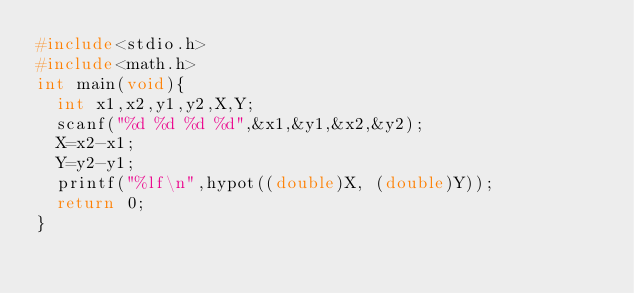Convert code to text. <code><loc_0><loc_0><loc_500><loc_500><_C_>#include<stdio.h>
#include<math.h>
int main(void){
	int x1,x2,y1,y2,X,Y;
	scanf("%d %d %d %d",&x1,&y1,&x2,&y2);
	X=x2-x1;
	Y=y2-y1;
	printf("%lf\n",hypot((double)X, (double)Y));
	return 0;
}</code> 